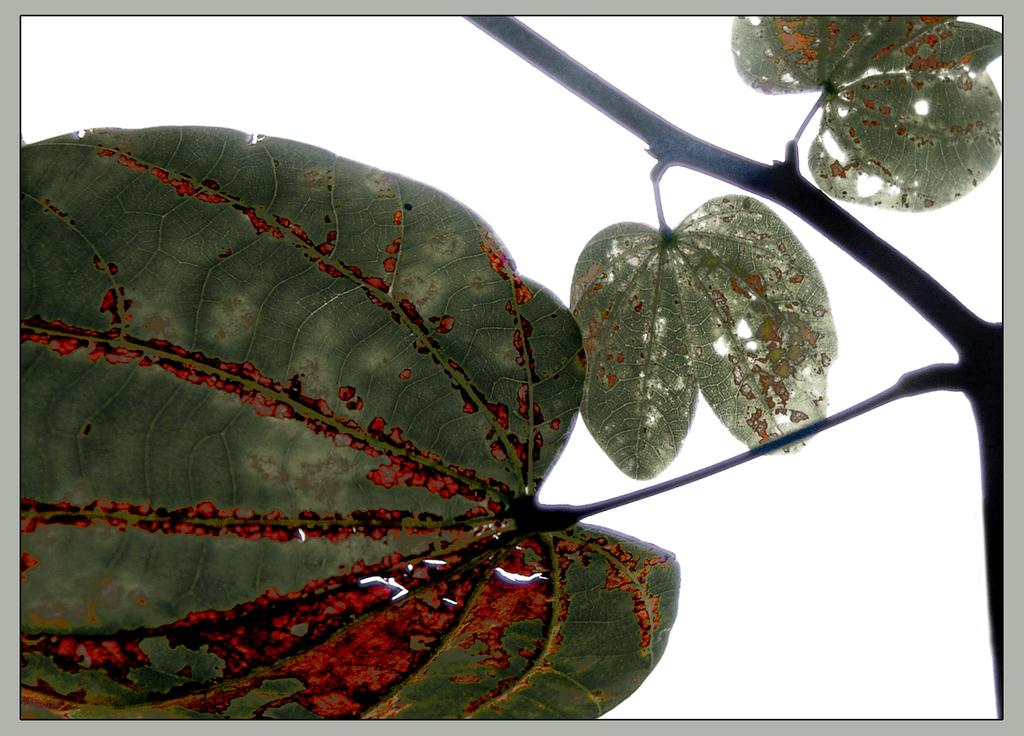What color are the leaves in the image? The leaves in the image are green. What color is the background of the image? The background of the image is white. Where are the stems located in the image? The stems are on the right side of the image. What type of rhythm can be heard from the farm in the image? There is no farm or any sound in the image, so it's not possible to determine what type of rhythm might be heard. 